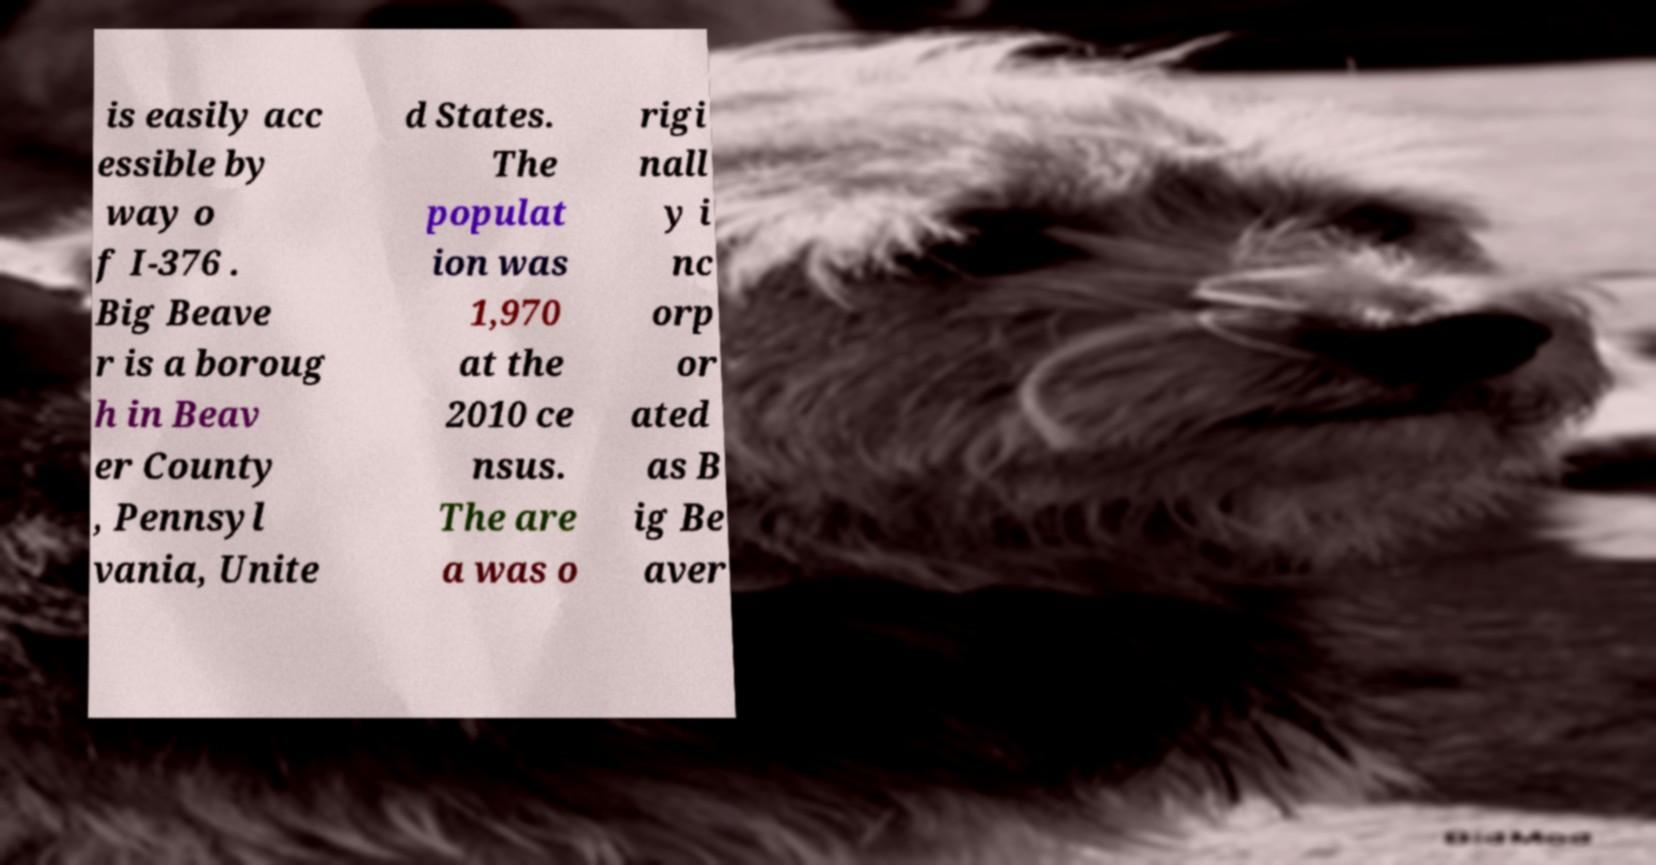Can you accurately transcribe the text from the provided image for me? is easily acc essible by way o f I-376 . Big Beave r is a boroug h in Beav er County , Pennsyl vania, Unite d States. The populat ion was 1,970 at the 2010 ce nsus. The are a was o rigi nall y i nc orp or ated as B ig Be aver 